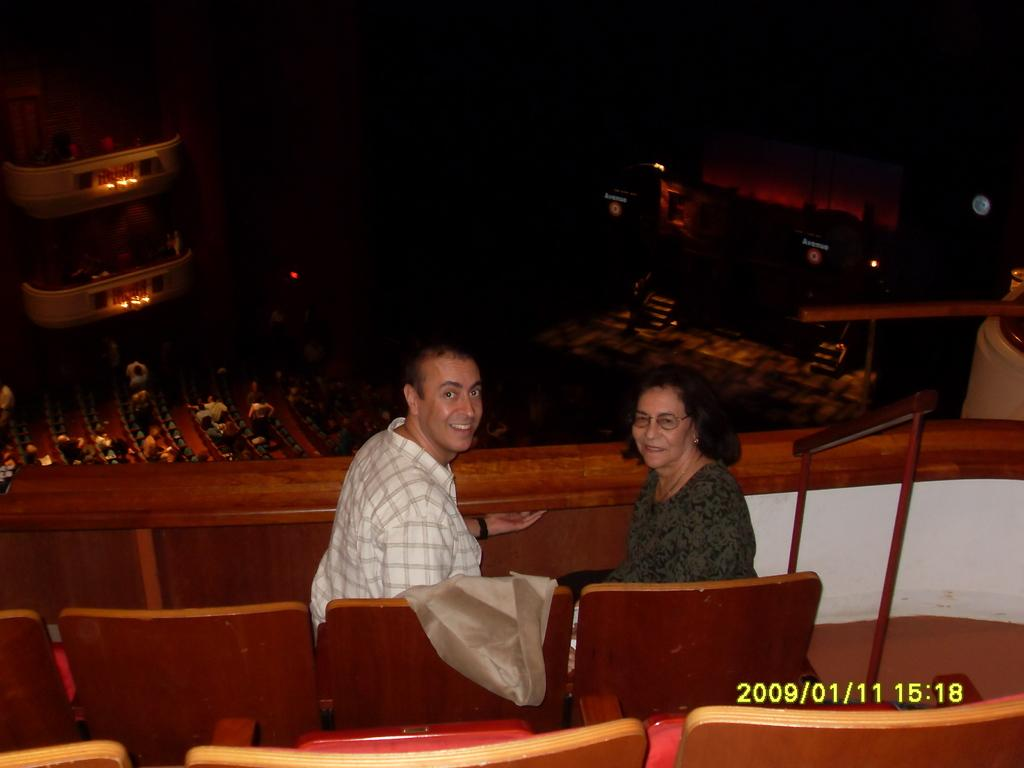How many people are sitting on chairs in the image? There are 2 people sitting on chairs on the top and an unspecified number of people sitting on chairs downstairs. Where are the people sitting in the image? The people are sitting on chairs both on the top and downstairs. What type of parcel is being delivered to the people sitting on chairs downstairs? There is no parcel visible or mentioned in the image. Can you describe the rat that is sitting on the chair next to the person on the top? There is no rat present in the image. 